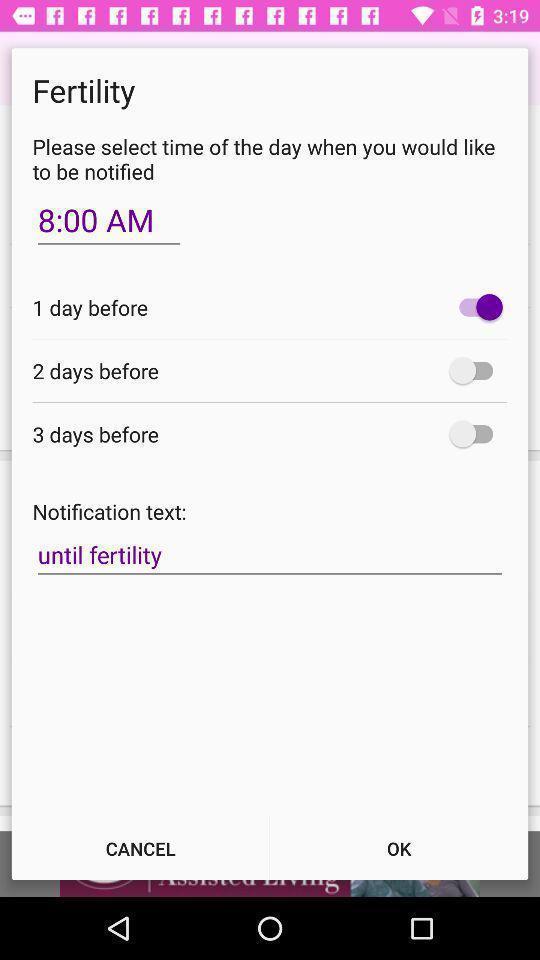Give me a summary of this screen capture. Pop up alert message of fertility. 